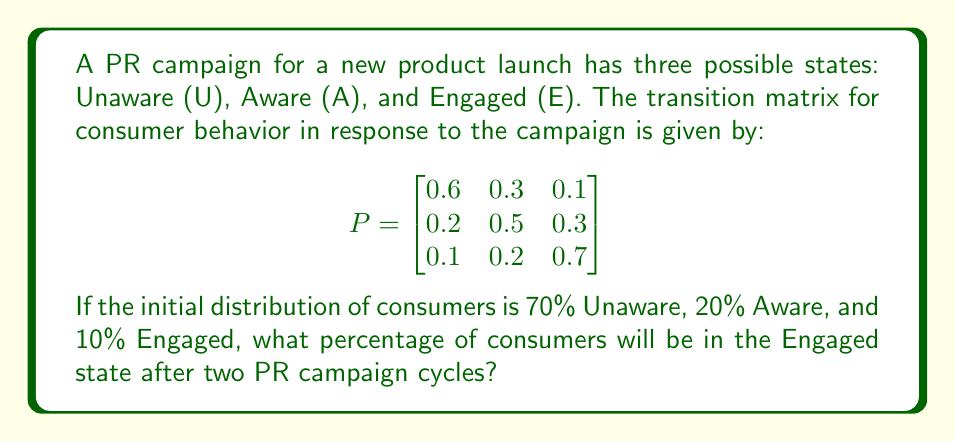Teach me how to tackle this problem. To solve this problem, we'll use Markov chain analysis:

1. Let's define the initial state vector:
   $$\pi_0 = [0.7, 0.2, 0.1]$$

2. To find the state after two cycles, we need to multiply the initial state by the transition matrix twice:
   $$\pi_2 = \pi_0 \cdot P^2$$

3. First, let's calculate $P^2$:
   $$P^2 = P \cdot P = \begin{bmatrix}
   0.6 & 0.3 & 0.1 \\
   0.2 & 0.5 & 0.3 \\
   0.1 & 0.2 & 0.7
   \end{bmatrix} \cdot \begin{bmatrix}
   0.6 & 0.3 & 0.1 \\
   0.2 & 0.5 & 0.3 \\
   0.1 & 0.2 & 0.7
   \end{bmatrix}$$

4. Performing the matrix multiplication:
   $$P^2 = \begin{bmatrix}
   0.43 & 0.33 & 0.24 \\
   0.29 & 0.40 & 0.31 \\
   0.19 & 0.28 & 0.53
   \end{bmatrix}$$

5. Now, we can calculate $\pi_2$:
   $$\pi_2 = [0.7, 0.2, 0.1] \cdot \begin{bmatrix}
   0.43 & 0.33 & 0.24 \\
   0.29 & 0.40 & 0.31 \\
   0.19 & 0.28 & 0.53
   \end{bmatrix}$$

6. Performing this multiplication:
   $$\pi_2 = [0.389, 0.343, 0.268]$$

7. The last element of $\pi_2$ represents the proportion of consumers in the Engaged state after two cycles.

8. Converting to a percentage: $0.268 \times 100\% = 26.8\%$
Answer: 26.8% 